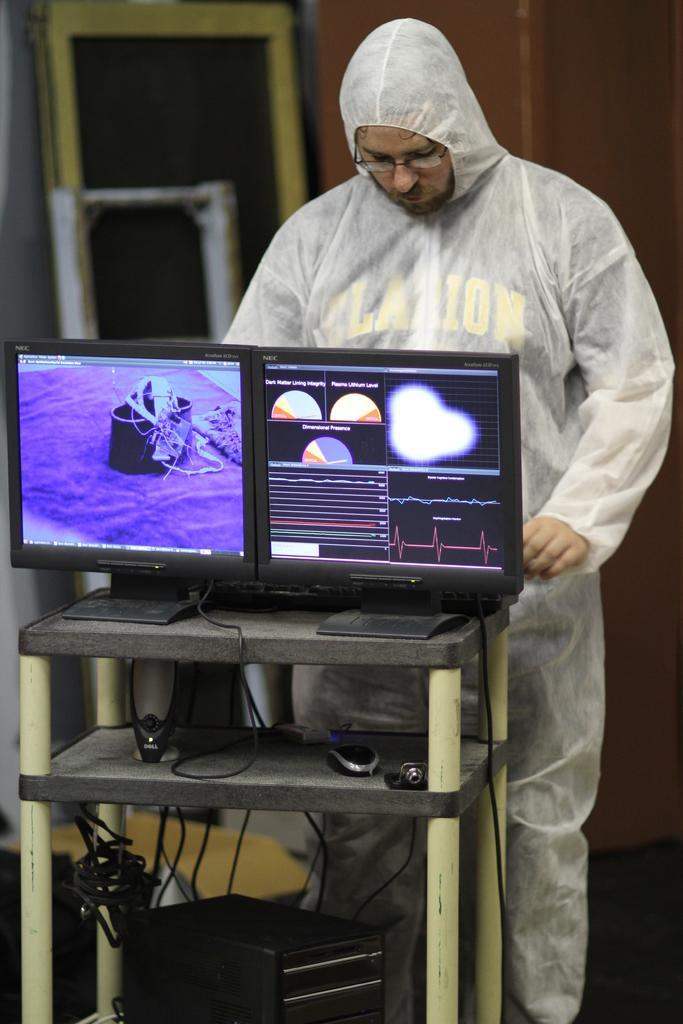How would you summarize this image in a sentence or two? There is one man standing on the right side of this image. We can see a computer kept on a table which is at the bottom of this image. We can see a wall in the background. 